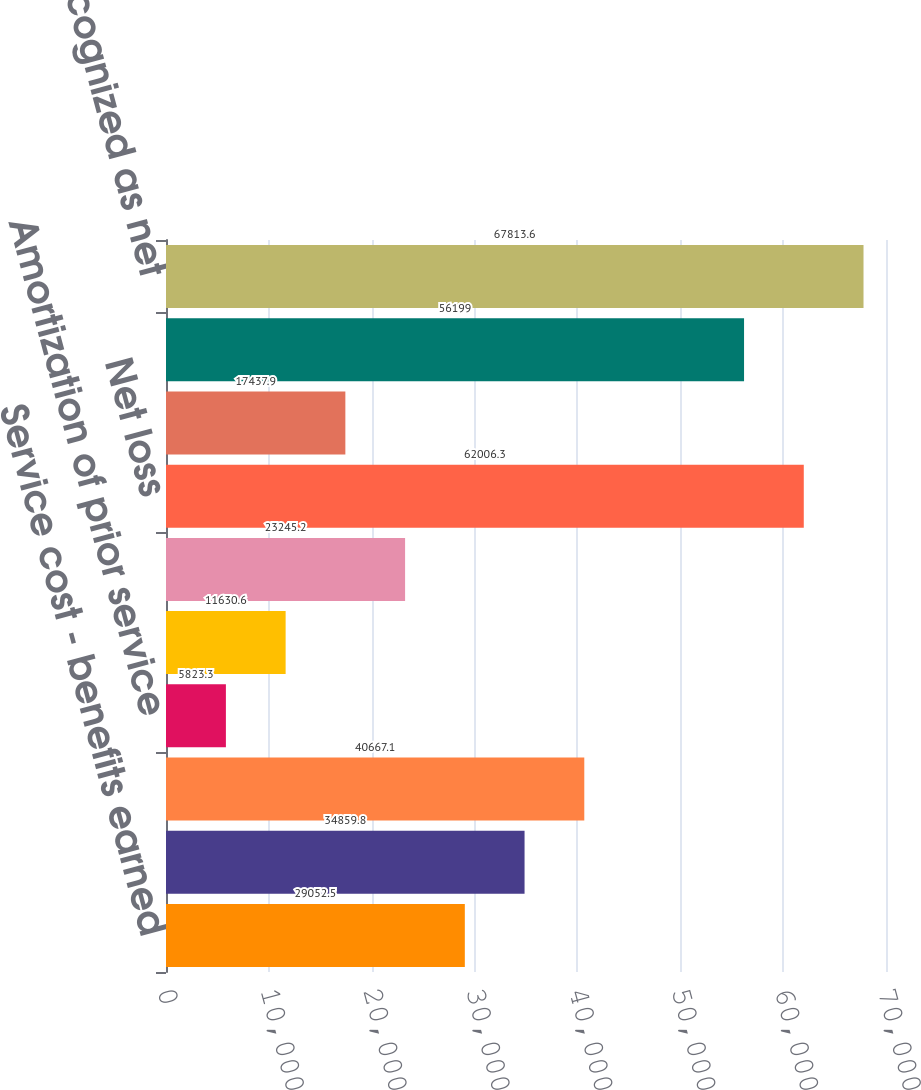Convert chart to OTSL. <chart><loc_0><loc_0><loc_500><loc_500><bar_chart><fcel>Service cost - benefits earned<fcel>Interest cost on projected<fcel>Expected return on assets<fcel>Amortization of prior service<fcel>Recognized net loss<fcel>Net pension cost<fcel>Net loss<fcel>Amortization of net loss<fcel>Total<fcel>Total recognized as net<nl><fcel>29052.5<fcel>34859.8<fcel>40667.1<fcel>5823.3<fcel>11630.6<fcel>23245.2<fcel>62006.3<fcel>17437.9<fcel>56199<fcel>67813.6<nl></chart> 